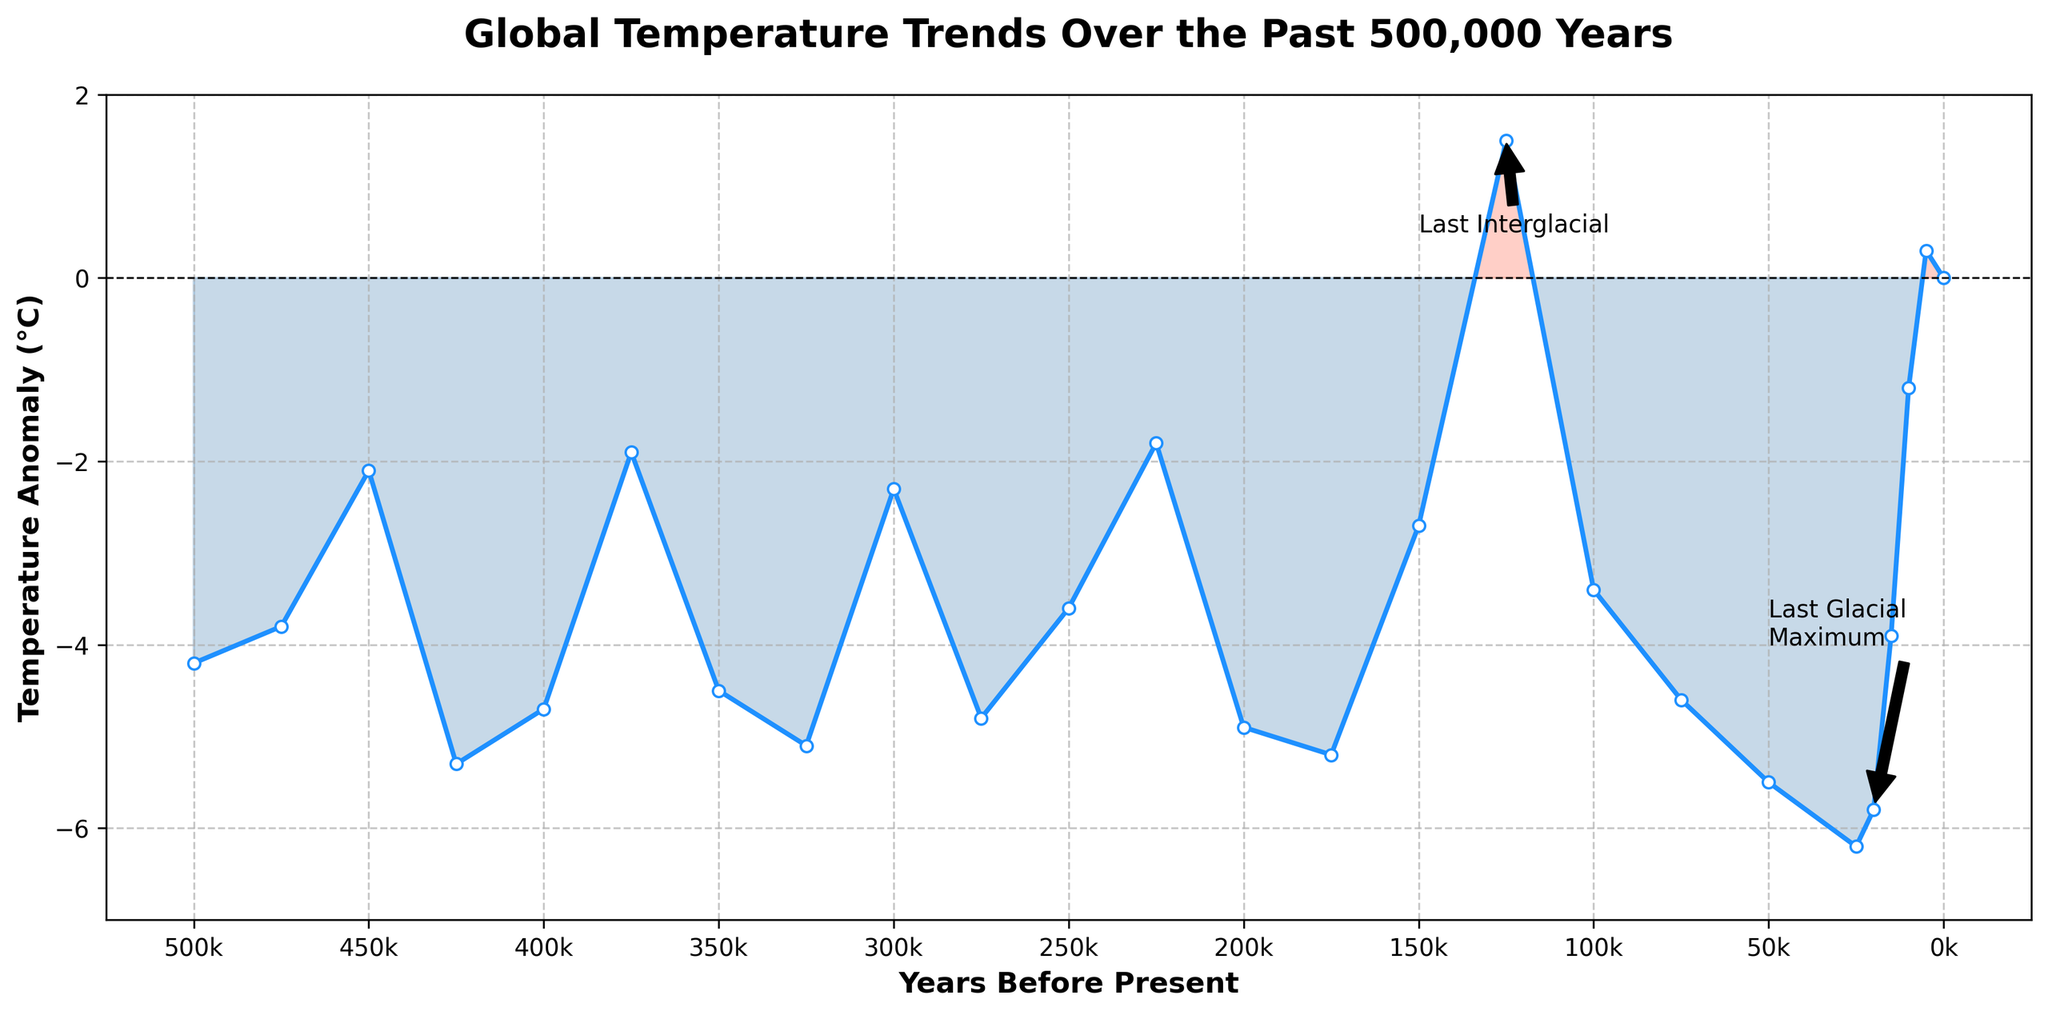What is the overall trend in global temperature anomalies over the past 500,000 years? The temperature anomalies show cyclical patterns with periods of colder temperatures (glacial periods) and warmer temperatures (interglacial periods). This cyclical trend indicates the alternation between glacial and interglacial periods over time. The most recent trend indicates movement towards a warmer (interglacial) period.
Answer: Cyclical with colder (glacial) and warmer (interglacial) periods Which period shows the highest temperature anomaly and what is its value? The highest temperature anomaly is observed around 125,000 years before present, labeled as the "Last Interglacial" period. This period is marked with a peak temperature anomaly of approximately 1.5°C.
Answer: 1.5°C at 125,000 years before present How does the temperature anomaly 20,000 years ago compare to the present day anomaly? The temperature anomaly 20,000 years ago is around -5.8°C, while the present day anomaly is 0°C. The temperature anomaly 20,000 years ago is significantly lower compared to the present day.
Answer: -5.8°C (20,000 years ago) vs 0°C (present day) What temperature anomaly range is observed at around 300,000 years before present? Examining the plot, around 300,000 years before present, the temperature anomaly is approximately -2.3°C.
Answer: Approximately -2.3°C Identify one major glacial and one major interglacial period within the past 200,000 years from the plot and state their temperature anomalies. A major glacial period within the past 200,000 years is approximately 20,000 years before present with a temperature anomaly of around -5.8°C. A major interglacial period is around 125,000 years before present, marked by a temperature anomaly of around 1.5°C.
Answer: Glacial: -5.8°C at 20,000 years before present. Interglacial: 1.5°C at 125,000 years before present What is the largest temperature anomaly difference observed within the past 100,000 years? The largest temperature anomaly difference within the past 100,000 years appears between the Last Glacial Maximum around 20,000 years before present (-5.8°C) and the Last Interglacial around 125,000 years before present (1.5°C). The difference is 1.5°C - (-5.8°C) = 7.3°C.
Answer: 7.3°C Compare the temperature anomalies at 200,000 years before present and 400,000 years before present. At 200,000 years before present, the temperature anomaly is approximately -4.9°C. At 400,000 years before present, the anomaly is around -4.7°C. The temperature anomaly at 200,000 years before present is slightly lower by 0.2°C compared to 400,000 years before present.
Answer: -4.9°C (200,000 years before present) vs -4.7°C (400,000 years before present) Highlight the period which shows the temperature anomaly crossing from negative to positive in the past 500,000 years. The period where the temperature anomaly crosses from negative to positive is around 125,000 years before present, known as the Last Interglacial period. This is the only significant positive anomaly in the past 500,000 years.
Answer: Around 125,000 years before present What are the two prominent temperature anomaly peaks in the last 500,000 years and their values? The two prominent peaks are around 125,000 years before present with a positive anomaly of 1.5°C (Last Interglacial), and around 20,000 years before present with a negative anomaly of -5.8°C (Last Glacial Maximum).
Answer: 1.5°C (125,000 years before present) and -5.8°C (20,000 years before present) 